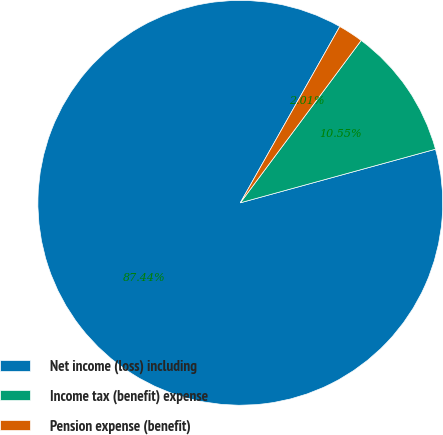<chart> <loc_0><loc_0><loc_500><loc_500><pie_chart><fcel>Net income (loss) including<fcel>Income tax (benefit) expense<fcel>Pension expense (benefit)<nl><fcel>87.44%<fcel>10.55%<fcel>2.01%<nl></chart> 